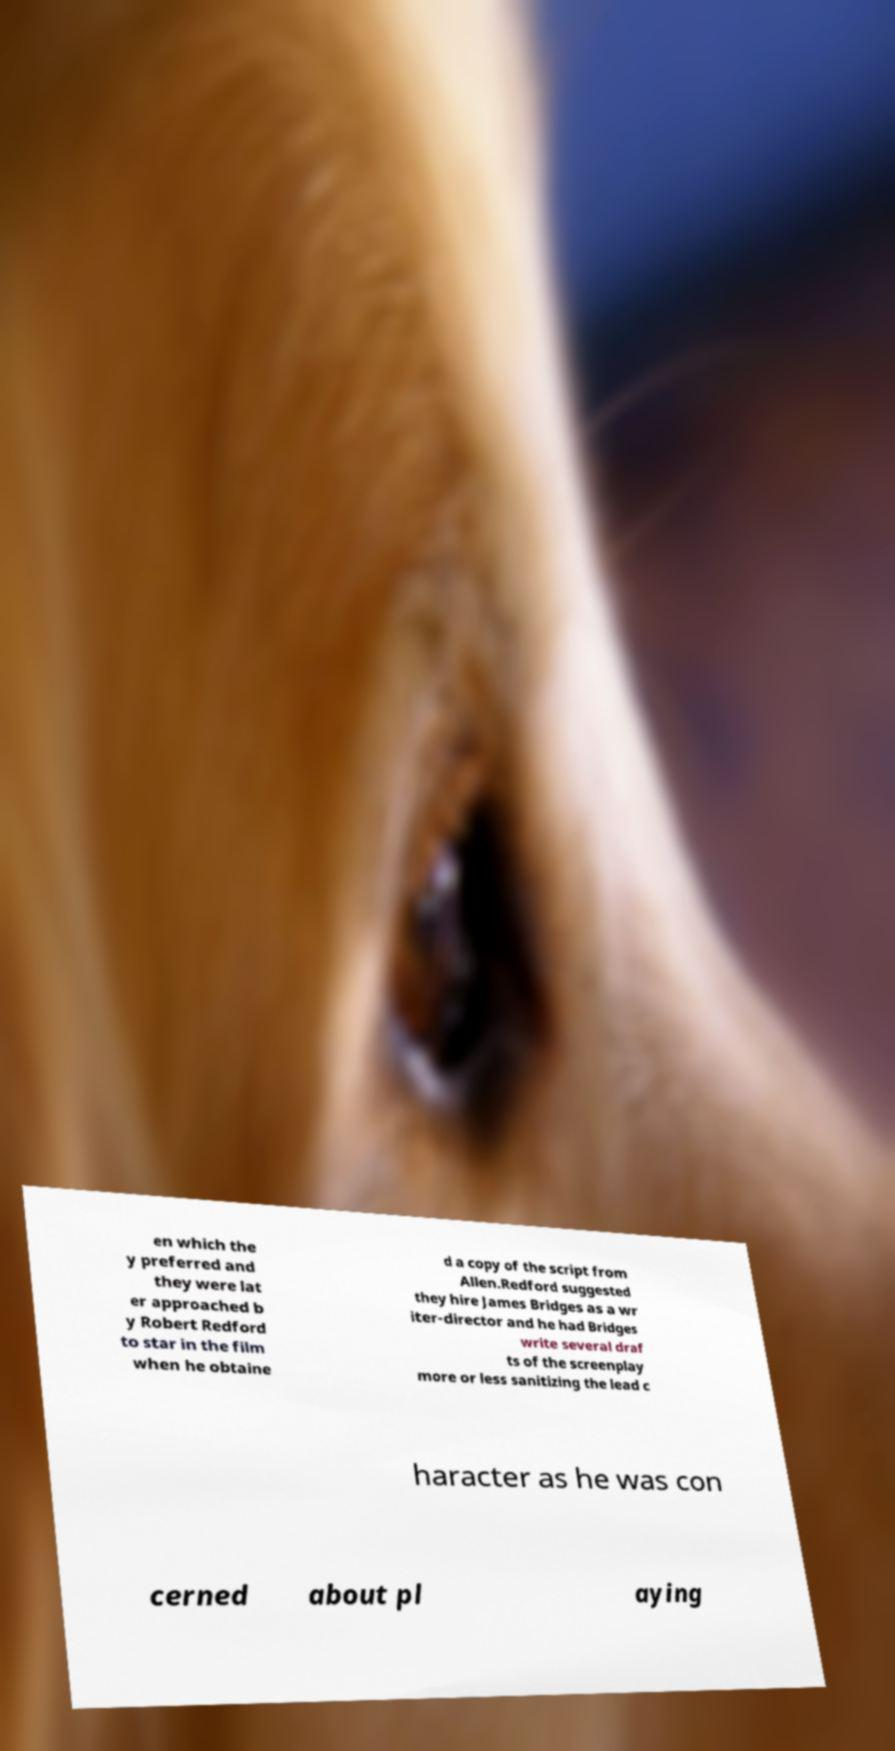Could you extract and type out the text from this image? en which the y preferred and they were lat er approached b y Robert Redford to star in the film when he obtaine d a copy of the script from Allen.Redford suggested they hire James Bridges as a wr iter-director and he had Bridges write several draf ts of the screenplay more or less sanitizing the lead c haracter as he was con cerned about pl aying 